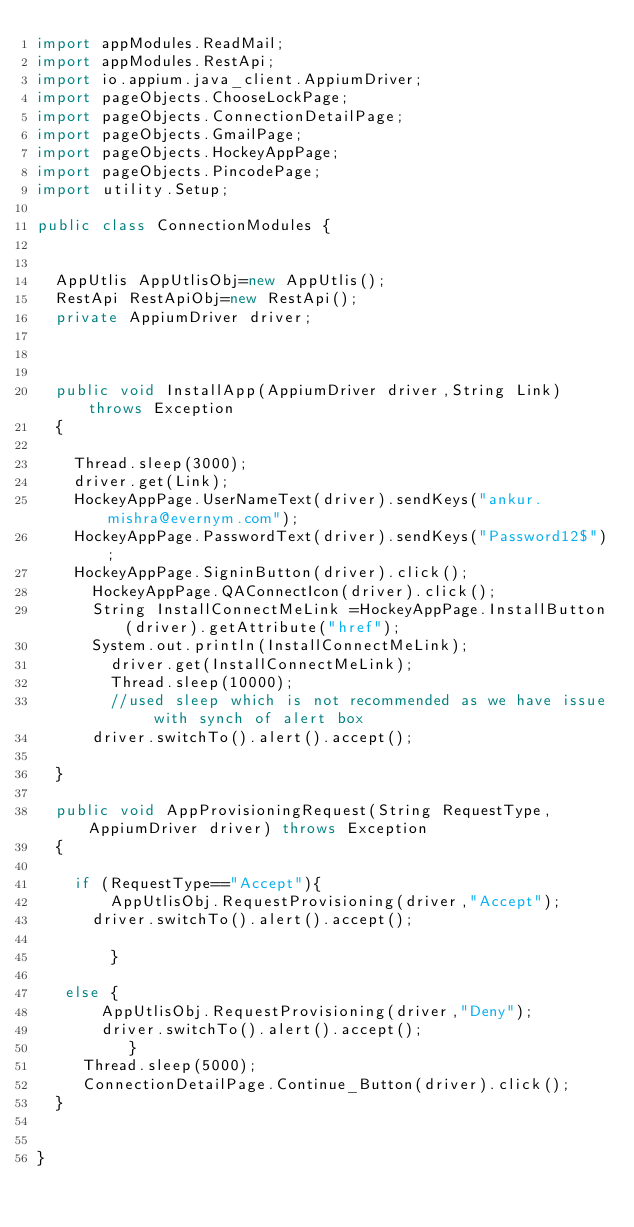Convert code to text. <code><loc_0><loc_0><loc_500><loc_500><_Java_>import appModules.ReadMail;
import appModules.RestApi;
import io.appium.java_client.AppiumDriver;
import pageObjects.ChooseLockPage;
import pageObjects.ConnectionDetailPage;
import pageObjects.GmailPage;
import pageObjects.HockeyAppPage;
import pageObjects.PincodePage;
import utility.Setup;

public class ConnectionModules {
	

	AppUtlis AppUtlisObj=new AppUtlis();
	RestApi RestApiObj=new RestApi();
	private AppiumDriver driver;

	
	
	public void InstallApp(AppiumDriver driver,String Link)throws Exception
	{
		
		Thread.sleep(3000);
		driver.get(Link);
		HockeyAppPage.UserNameText(driver).sendKeys("ankur.mishra@evernym.com");
		HockeyAppPage.PasswordText(driver).sendKeys("Password12$");
		HockeyAppPage.SigninButton(driver).click();    	
     	HockeyAppPage.QAConnectIcon(driver).click(); 
     	String InstallConnectMeLink =HockeyAppPage.InstallButton(driver).getAttribute("href");
     	System.out.println(InstallConnectMeLink);
        driver.get(InstallConnectMeLink);
        Thread.sleep(10000);
        //used sleep which is not recommended as we have issue with synch of alert box
    	driver.switchTo().alert().accept();
		
	}

	public void AppProvisioningRequest(String RequestType,AppiumDriver driver) throws Exception
	{

		if (RequestType=="Accept"){
	      AppUtlisObj.RequestProvisioning(driver,"Accept");
		  driver.switchTo().alert().accept();

	      }
		
	 else {
		   AppUtlisObj.RequestProvisioning(driver,"Deny");
		   driver.switchTo().alert().accept(); 
   	      }
	   Thread.sleep(5000);
	   ConnectionDetailPage.Continue_Button(driver).click();
	}
	

}
</code> 